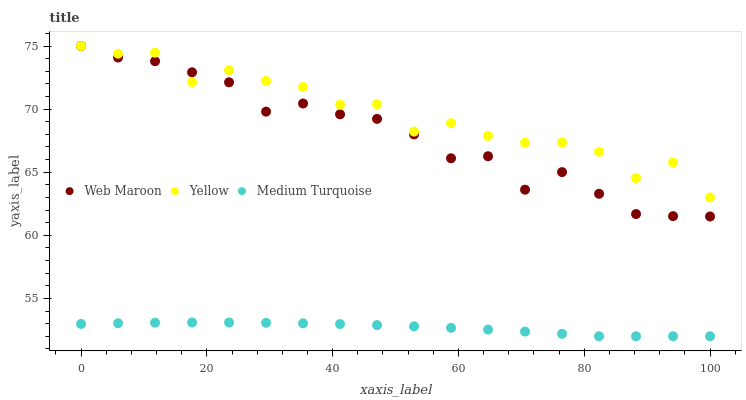Does Medium Turquoise have the minimum area under the curve?
Answer yes or no. Yes. Does Yellow have the maximum area under the curve?
Answer yes or no. Yes. Does Yellow have the minimum area under the curve?
Answer yes or no. No. Does Medium Turquoise have the maximum area under the curve?
Answer yes or no. No. Is Medium Turquoise the smoothest?
Answer yes or no. Yes. Is Yellow the roughest?
Answer yes or no. Yes. Is Yellow the smoothest?
Answer yes or no. No. Is Medium Turquoise the roughest?
Answer yes or no. No. Does Medium Turquoise have the lowest value?
Answer yes or no. Yes. Does Yellow have the lowest value?
Answer yes or no. No. Does Yellow have the highest value?
Answer yes or no. Yes. Does Medium Turquoise have the highest value?
Answer yes or no. No. Is Medium Turquoise less than Yellow?
Answer yes or no. Yes. Is Web Maroon greater than Medium Turquoise?
Answer yes or no. Yes. Does Web Maroon intersect Yellow?
Answer yes or no. Yes. Is Web Maroon less than Yellow?
Answer yes or no. No. Is Web Maroon greater than Yellow?
Answer yes or no. No. Does Medium Turquoise intersect Yellow?
Answer yes or no. No. 